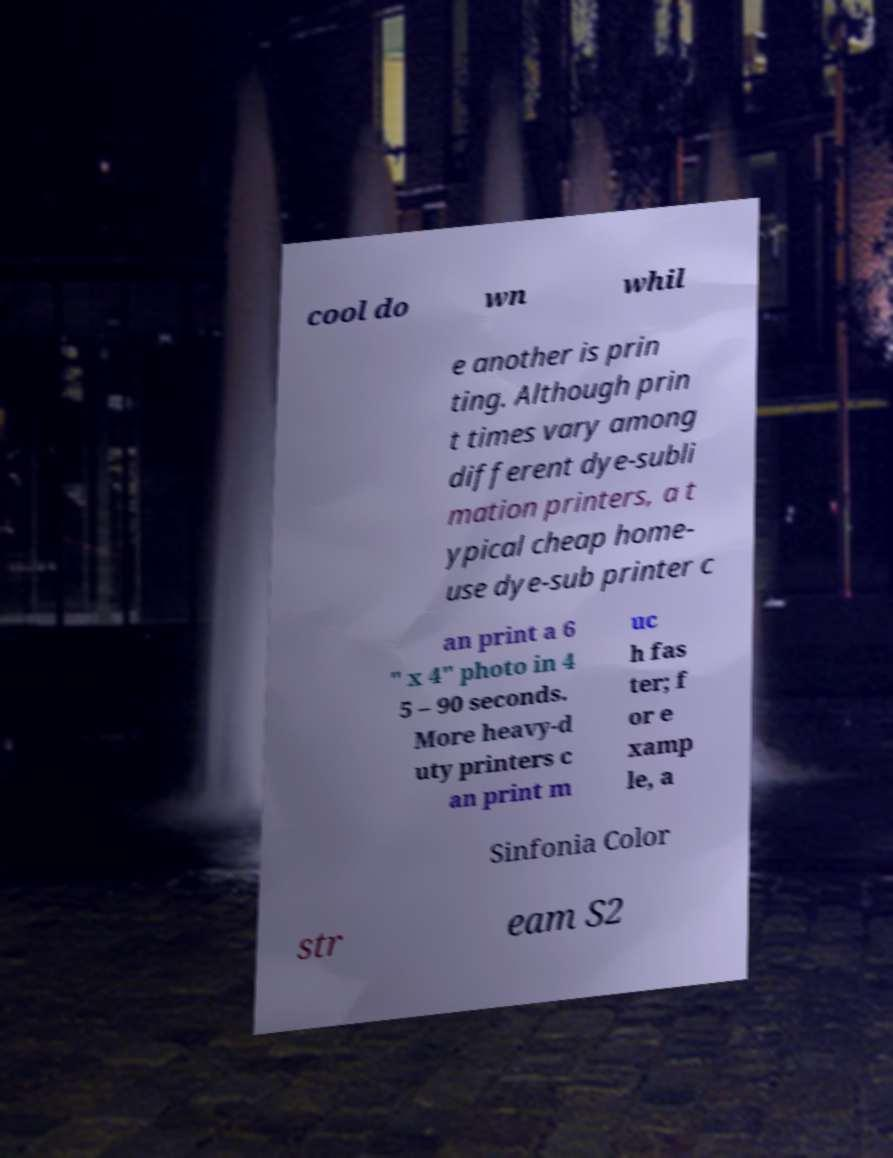Can you accurately transcribe the text from the provided image for me? cool do wn whil e another is prin ting. Although prin t times vary among different dye-subli mation printers, a t ypical cheap home- use dye-sub printer c an print a 6 " x 4" photo in 4 5 – 90 seconds. More heavy-d uty printers c an print m uc h fas ter; f or e xamp le, a Sinfonia Color str eam S2 